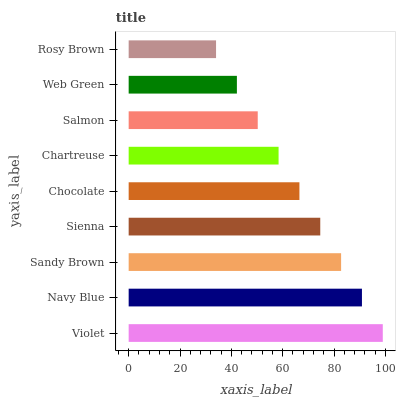Is Rosy Brown the minimum?
Answer yes or no. Yes. Is Violet the maximum?
Answer yes or no. Yes. Is Navy Blue the minimum?
Answer yes or no. No. Is Navy Blue the maximum?
Answer yes or no. No. Is Violet greater than Navy Blue?
Answer yes or no. Yes. Is Navy Blue less than Violet?
Answer yes or no. Yes. Is Navy Blue greater than Violet?
Answer yes or no. No. Is Violet less than Navy Blue?
Answer yes or no. No. Is Chocolate the high median?
Answer yes or no. Yes. Is Chocolate the low median?
Answer yes or no. Yes. Is Sandy Brown the high median?
Answer yes or no. No. Is Navy Blue the low median?
Answer yes or no. No. 